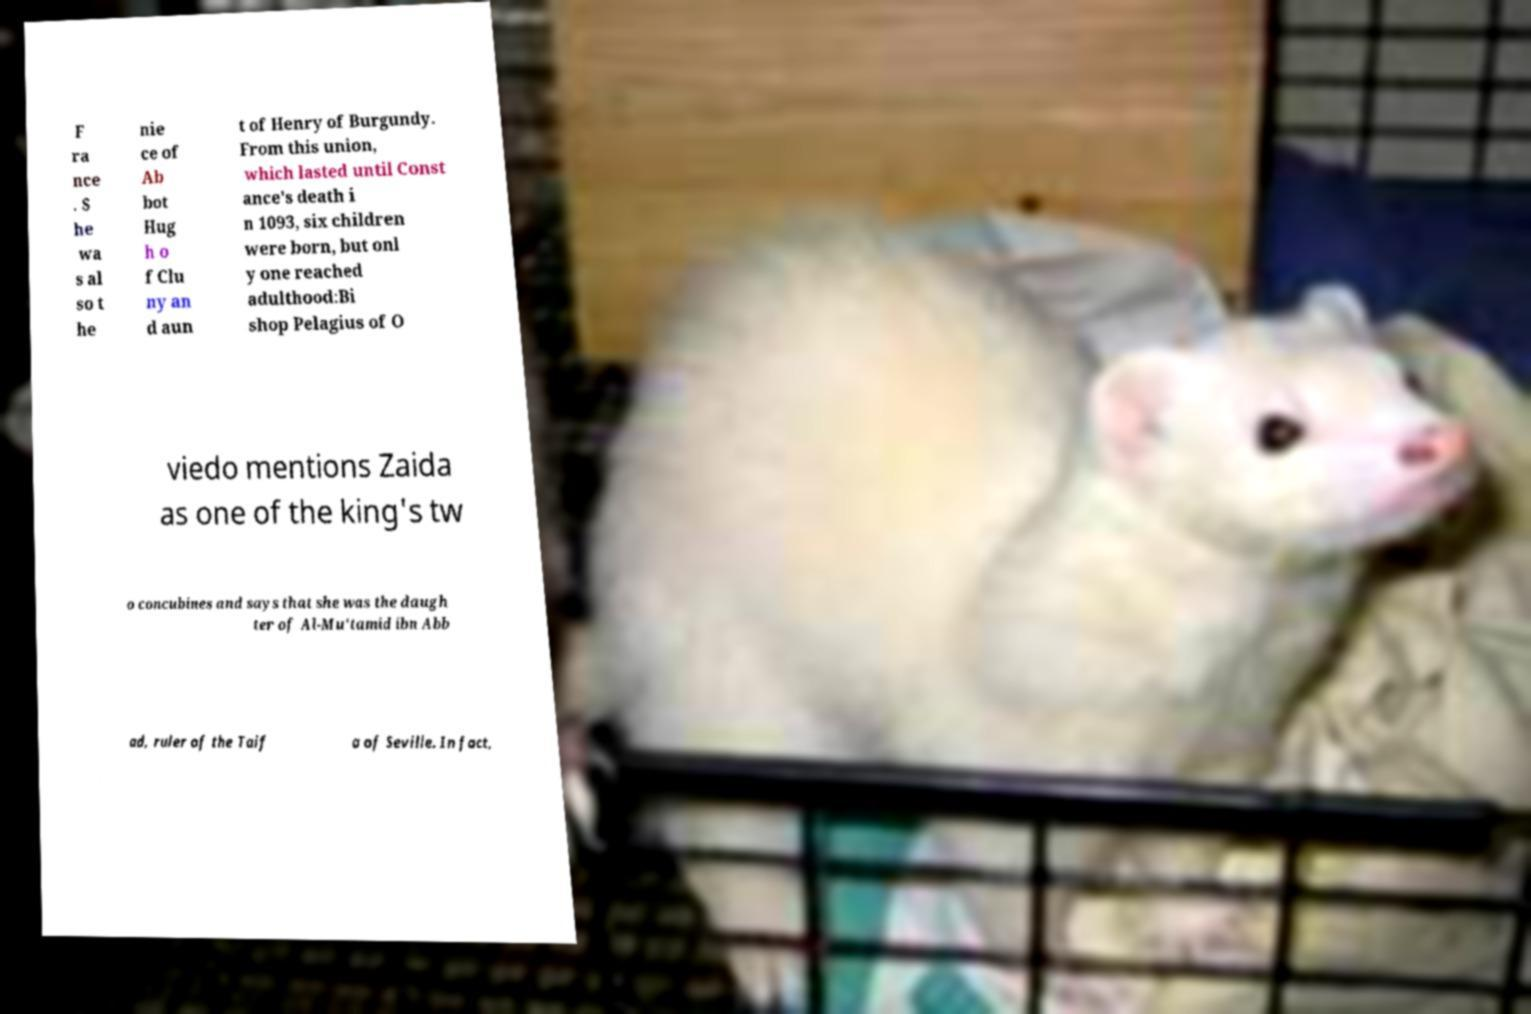Please read and relay the text visible in this image. What does it say? F ra nce . S he wa s al so t he nie ce of Ab bot Hug h o f Clu ny an d aun t of Henry of Burgundy. From this union, which lasted until Const ance's death i n 1093, six children were born, but onl y one reached adulthood:Bi shop Pelagius of O viedo mentions Zaida as one of the king's tw o concubines and says that she was the daugh ter of Al-Mu'tamid ibn Abb ad, ruler of the Taif a of Seville. In fact, 